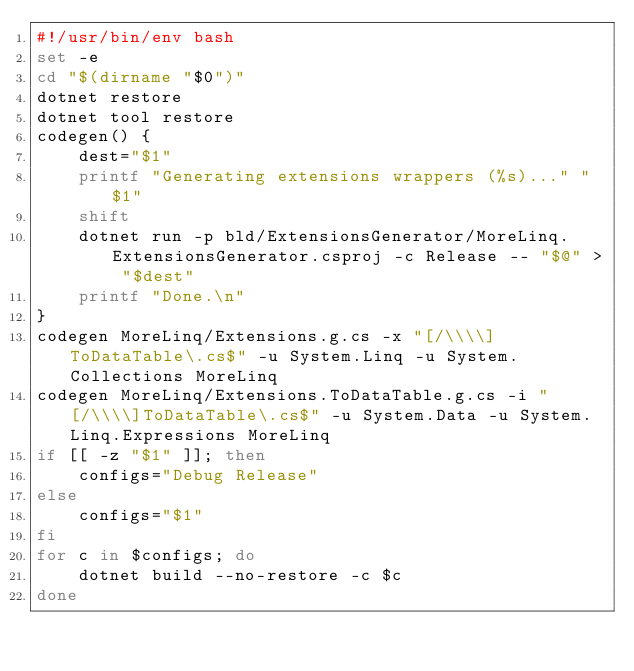Convert code to text. <code><loc_0><loc_0><loc_500><loc_500><_Bash_>#!/usr/bin/env bash
set -e
cd "$(dirname "$0")"
dotnet restore
dotnet tool restore
codegen() {
    dest="$1"
    printf "Generating extensions wrappers (%s)..." "$1"
    shift
    dotnet run -p bld/ExtensionsGenerator/MoreLinq.ExtensionsGenerator.csproj -c Release -- "$@" > "$dest"
    printf "Done.\n"
}
codegen MoreLinq/Extensions.g.cs -x "[/\\\\]ToDataTable\.cs$" -u System.Linq -u System.Collections MoreLinq
codegen MoreLinq/Extensions.ToDataTable.g.cs -i "[/\\\\]ToDataTable\.cs$" -u System.Data -u System.Linq.Expressions MoreLinq
if [[ -z "$1" ]]; then
    configs="Debug Release"
else
    configs="$1"
fi
for c in $configs; do
    dotnet build --no-restore -c $c
done
</code> 